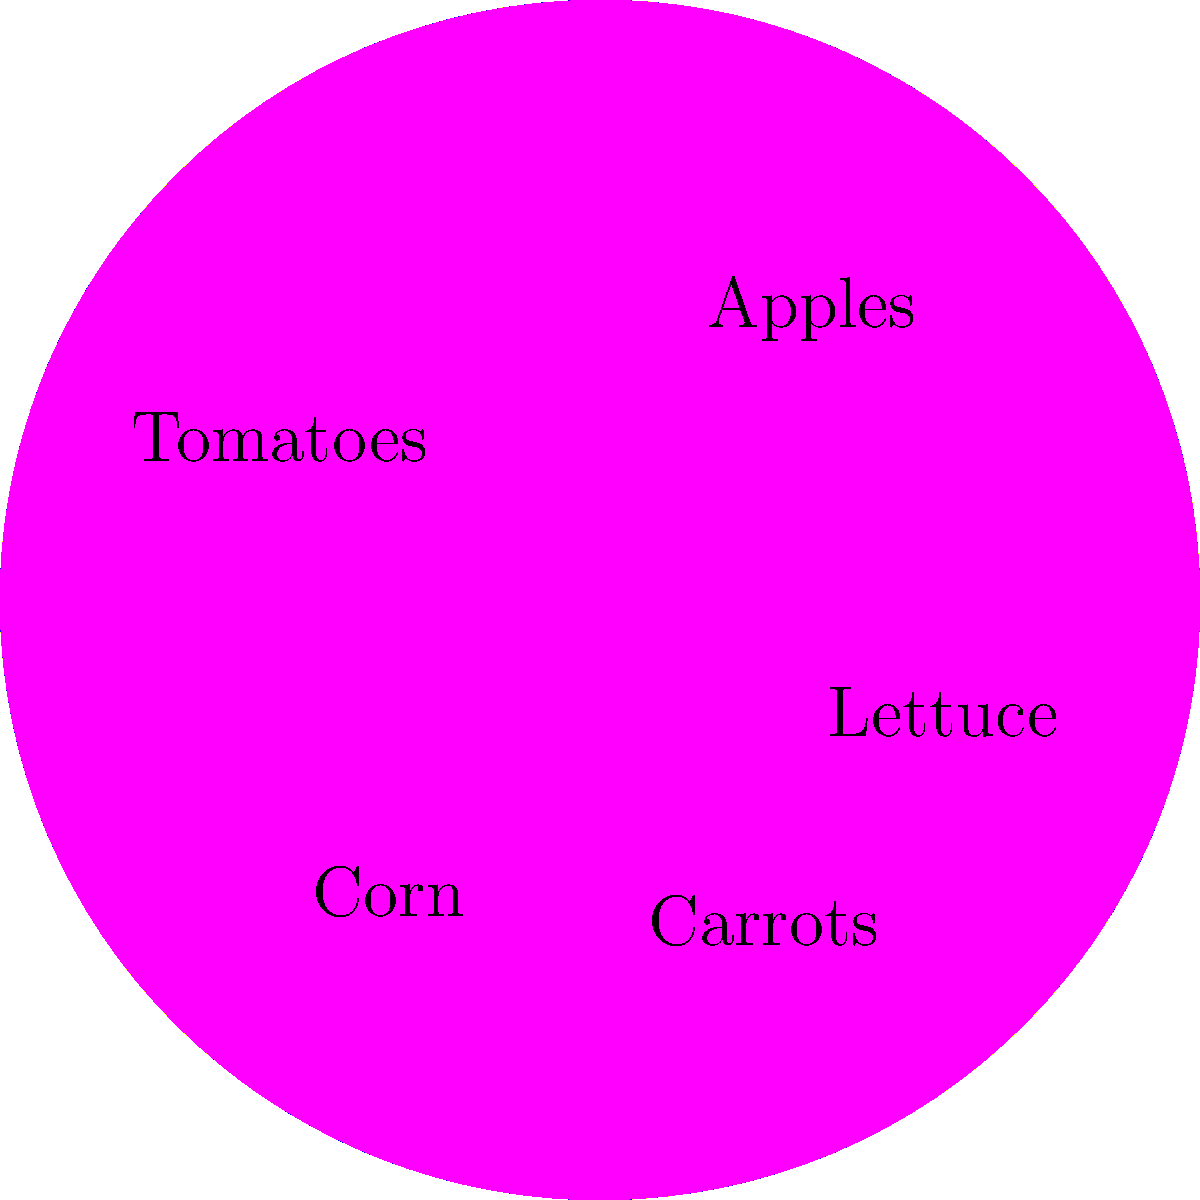You and the dairy farmer have agreed to divide your produce based on the pie chart shown. If the total value of the produce is $1000, and you want to trade half of your tomatoes for dairy products, how much monetary value of tomatoes (in dollars) will you trade? To solve this problem, let's follow these steps:

1. Identify the portion of tomatoes in the pie chart:
   The pie chart shows that tomatoes make up 25% of the total produce.

2. Calculate the total value of tomatoes:
   Total value of produce = $1000
   Percentage of tomatoes = 25%
   Value of tomatoes = $1000 * 25% = $1000 * 0.25 = $250

3. Determine the value of tomatoes to be traded:
   You want to trade half of your tomatoes.
   Half of $250 = $250 / 2 = $125

Therefore, you will trade $125 worth of tomatoes for dairy products.
Answer: $125 